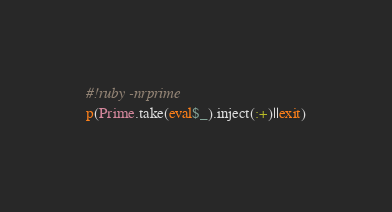<code> <loc_0><loc_0><loc_500><loc_500><_Ruby_>#!ruby -nrprime
p(Prime.take(eval$_).inject(:+)||exit)</code> 